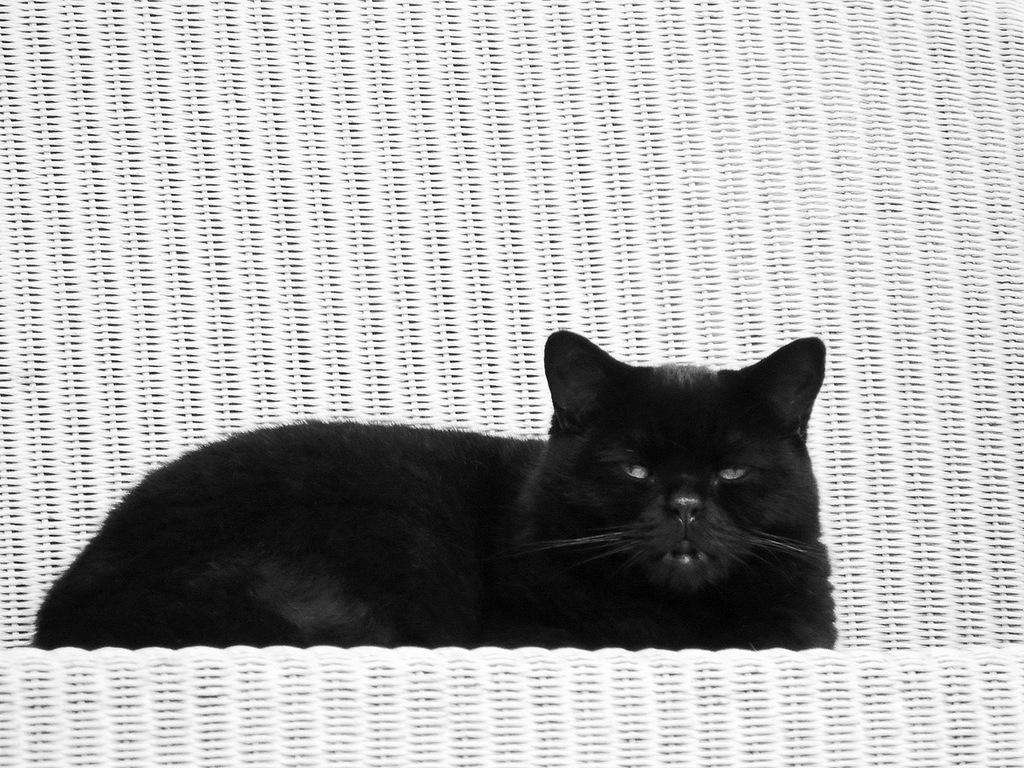What type of animal is in the image? There is a black color cat in the image. What is the cat sitting on? The cat is sitting in a white chair. What type of sweater is the cat wearing in the image? The cat is not wearing a sweater in the image; it is a cat and does not wear clothing. 